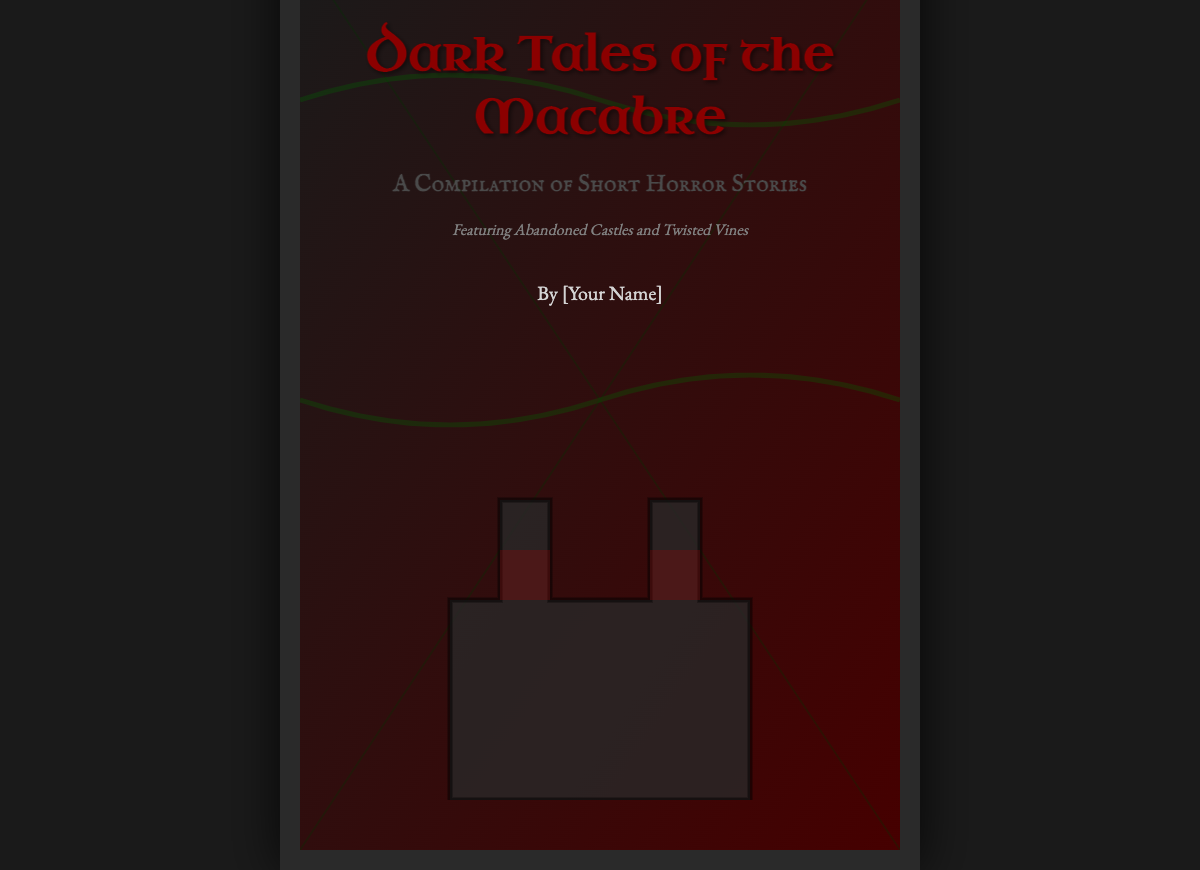What is the title of the book? The title of the book is prominently displayed in the header as "Dark Tales of the Macabre."
Answer: Dark Tales of the Macabre Who is the author of the book? The author's name is provided below the main content but is shown as "[Your Name]."
Answer: [Your Name] What genre does this book belong to? The genre is specified in the subtitle as a "Compilation of Short Horror Stories."
Answer: Horror What visual elements are featured on the cover? The cover illustrates "Abandoned Castles and Twisted Vines" as noted in the description below the subtitle.
Answer: Abandoned Castles and Twisted Vines What is the primary color scheme of the book cover? The book cover features dark colors, particularly with a background gradient of dark gray and deep red.
Answer: Dark gray and deep red How large is the book cover in pixels? The dimensions of the book cover are specified as "600px by 900px."
Answer: 600 by 900 What type of artwork is used in the illustrations? The illustrations are designed using specific SVG graphics, featuring gothic elements typical of dark themes.
Answer: SVG graphics What font is used for the title? The title uses a unique cursive font named "Uncial Antiqua."
Answer: Uncial Antiqua What type of tales does the compilation include? The compilation includes "Dark Tales of the Macabre," indicating a focus on the macabre and horror elements.
Answer: Dark Tales of the Macabre 